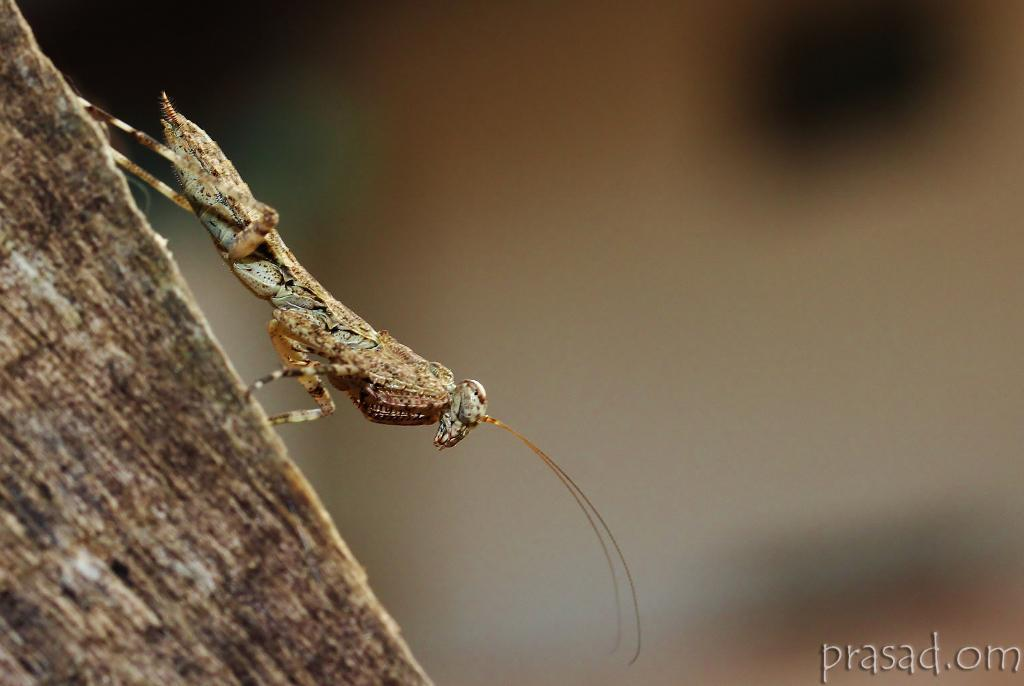What type of creature can be seen in the image? There is an insect in the image. What other feature is present in the image? There is a water mark in the image. How would you describe the background of the image? The background of the image is blurred. What type of agreement is being signed by the duck in the image? There is no duck present in the image, and therefore no agreement being signed. 